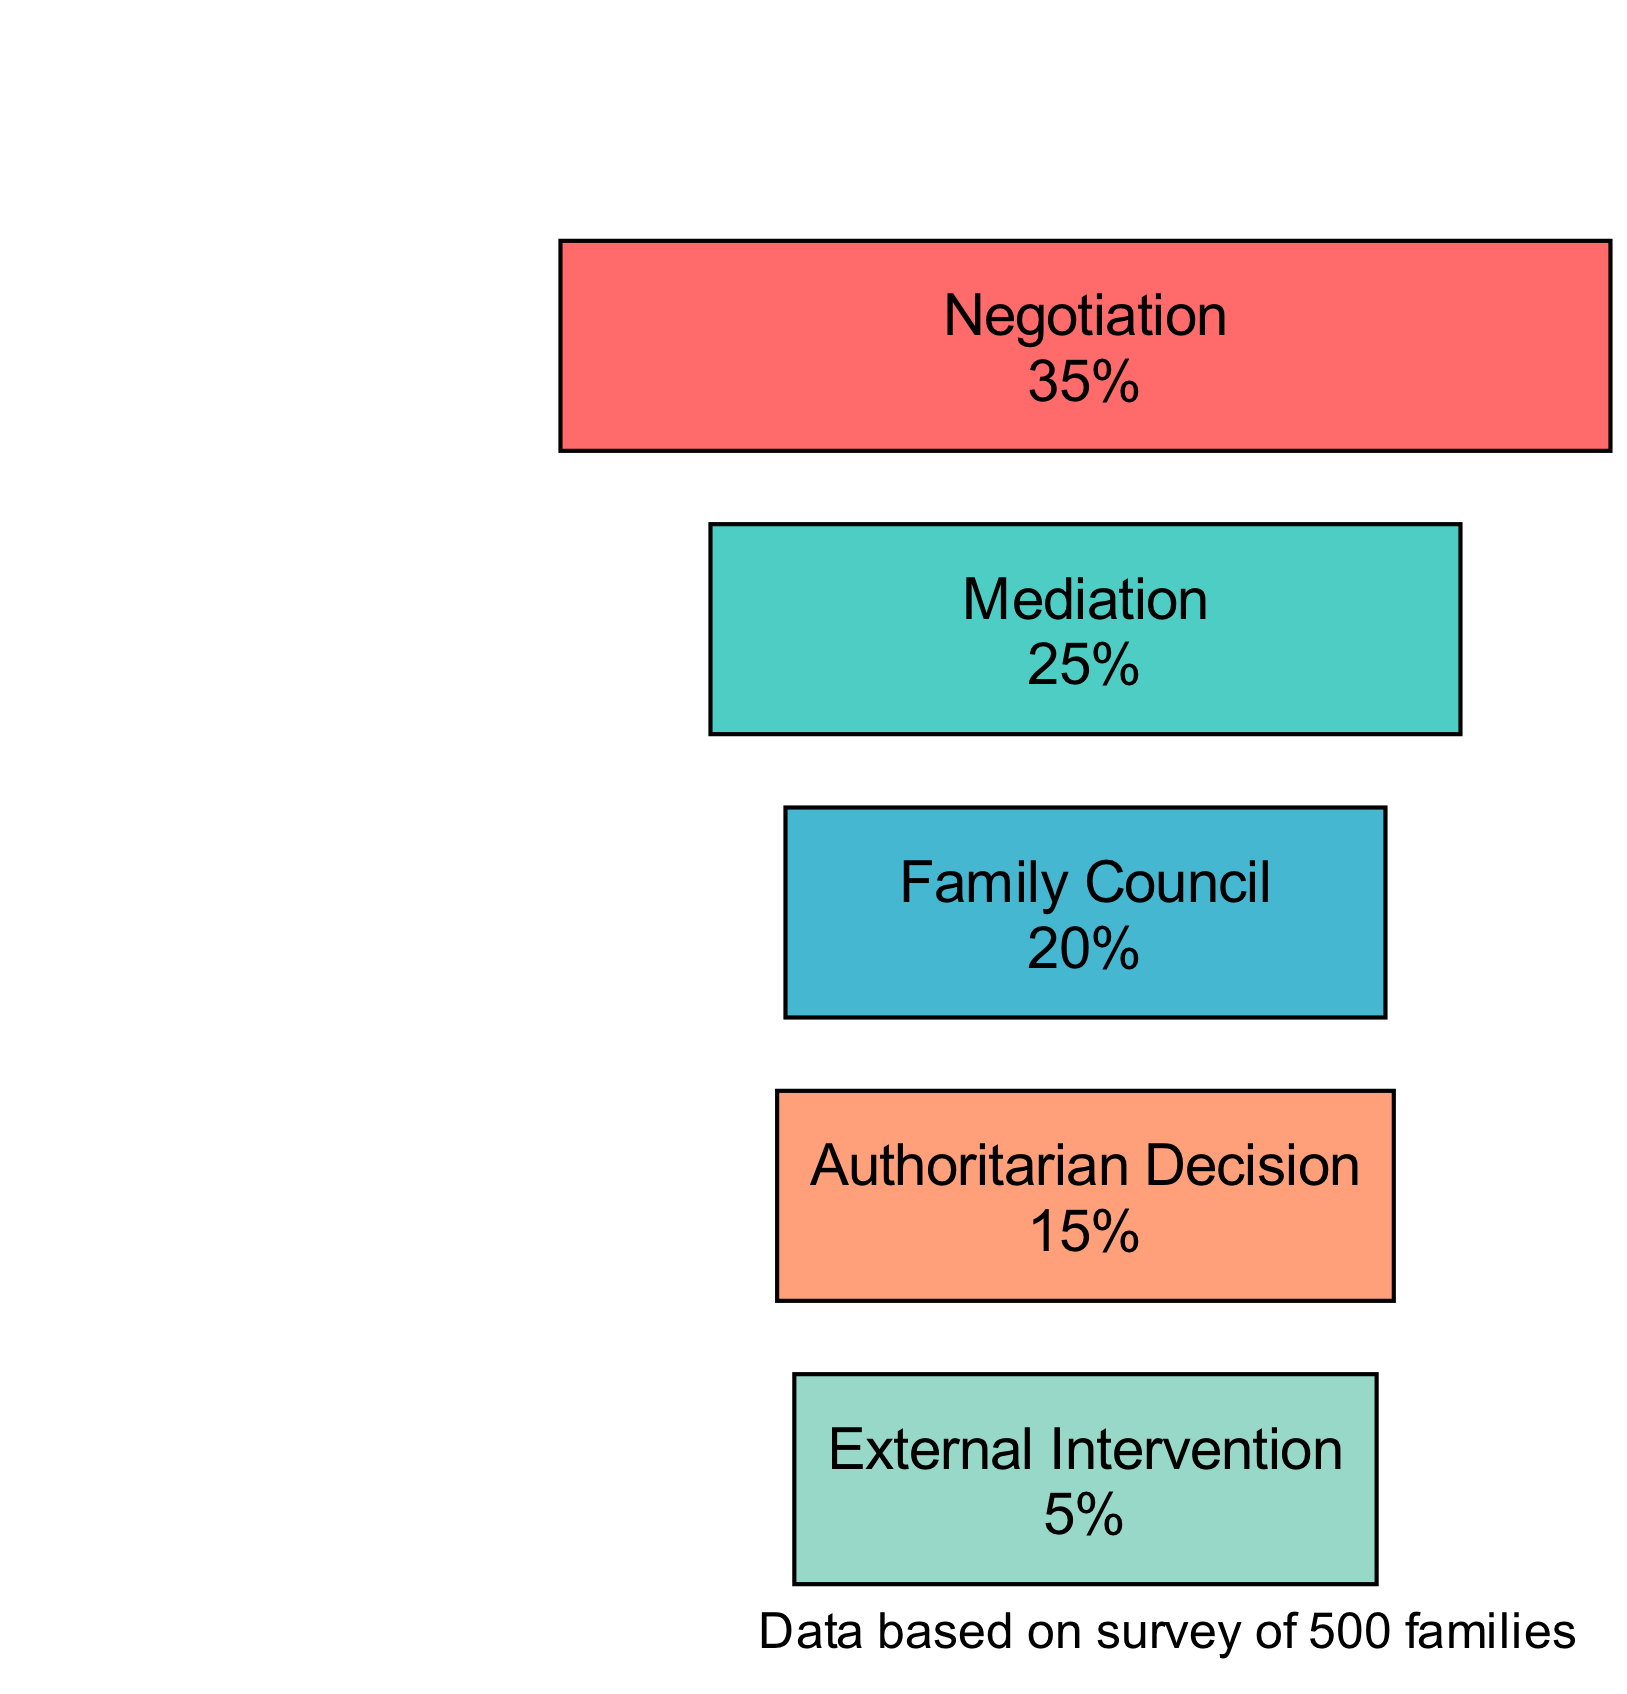What is the frequency of Mediation as a conflict resolution method? The diagram shows a bar representing Mediation. The height of the bar indicates the frequency percentage, which is labeled directly on it. According to the data, Mediation has a frequency of 25%.
Answer: 25% Which conflict resolution method has the highest frequency? By examining the heights of the bars representing different methods, Negotiation stands out as the tallest bar on the diagram, indicating it has the highest frequency among all methods. It is labeled with a frequency of 35%.
Answer: Negotiation What percentage of families use Authoritarian Decision for resolving conflicts? The diagram features a bar for Authoritarian Decision that shows its height, which corresponds to its frequency percentage. The bar is labeled with a frequency of 15%.
Answer: 15% How many conflict resolution methods are represented in the diagram? The diagram contains distinct bars for each resolution method. Counting the bars visually or from the data provided, there are five different methods represented on the diagram.
Answer: 5 What is the frequency difference between Family Council and External Intervention? To find the frequency difference, we look at the frequencies of both methods. Family Council has a frequency of 20%, and External Intervention has a frequency of 5%. The difference is calculated as 20% - 5% = 15%.
Answer: 15% Which method has a frequency lower than 10%? Examining the frequency labels on the bars, External Intervention stands out with a frequency of 5%, which is the only method with a frequency lower than 10%.
Answer: External Intervention What fraction of families used Mediation compared to those using Family Council? The diagram contains the frequencies for both Mediation (25%) and Family Council (20%). To find the fraction, we compare these two values. Thus, the fraction of families using Mediation compared to Family Council is 25% to 20%, which simplifies to 5:4.
Answer: 5:4 What color is used for the bar representing Negotiation? The diagram uses specific colors for each bar. The bar for Negotiation is filled with the color represented in the scheme, which corresponds to the first mentioned color in the data. The color for Negotiation is '#FF6B6B', a shade of red.
Answer: #FF6B6B 